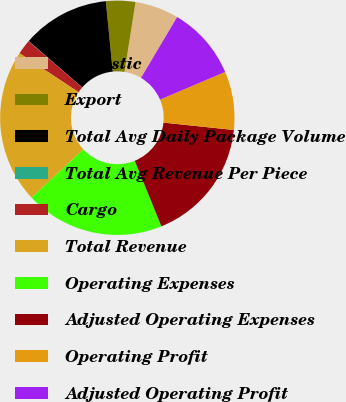Convert chart. <chart><loc_0><loc_0><loc_500><loc_500><pie_chart><fcel>Domestic<fcel>Export<fcel>Total Avg Daily Package Volume<fcel>Total Avg Revenue Per Piece<fcel>Cargo<fcel>Total Revenue<fcel>Operating Expenses<fcel>Adjusted Operating Expenses<fcel>Operating Profit<fcel>Adjusted Operating Profit<nl><fcel>6.05%<fcel>4.05%<fcel>12.08%<fcel>0.03%<fcel>2.04%<fcel>21.22%<fcel>19.21%<fcel>17.2%<fcel>8.06%<fcel>10.07%<nl></chart> 